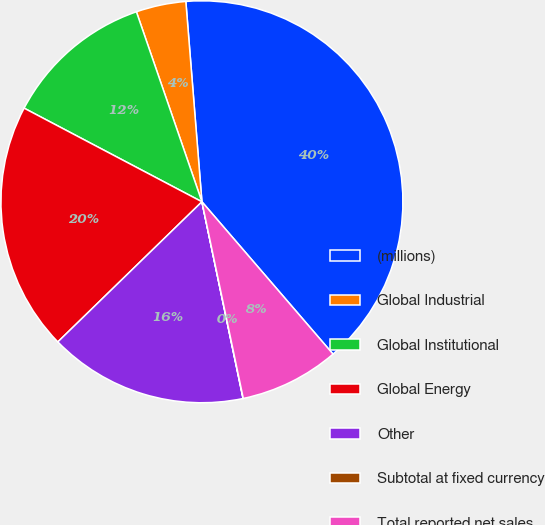Convert chart to OTSL. <chart><loc_0><loc_0><loc_500><loc_500><pie_chart><fcel>(millions)<fcel>Global Industrial<fcel>Global Institutional<fcel>Global Energy<fcel>Other<fcel>Subtotal at fixed currency<fcel>Total reported net sales<nl><fcel>39.96%<fcel>4.01%<fcel>12.0%<fcel>19.99%<fcel>16.0%<fcel>0.02%<fcel>8.01%<nl></chart> 